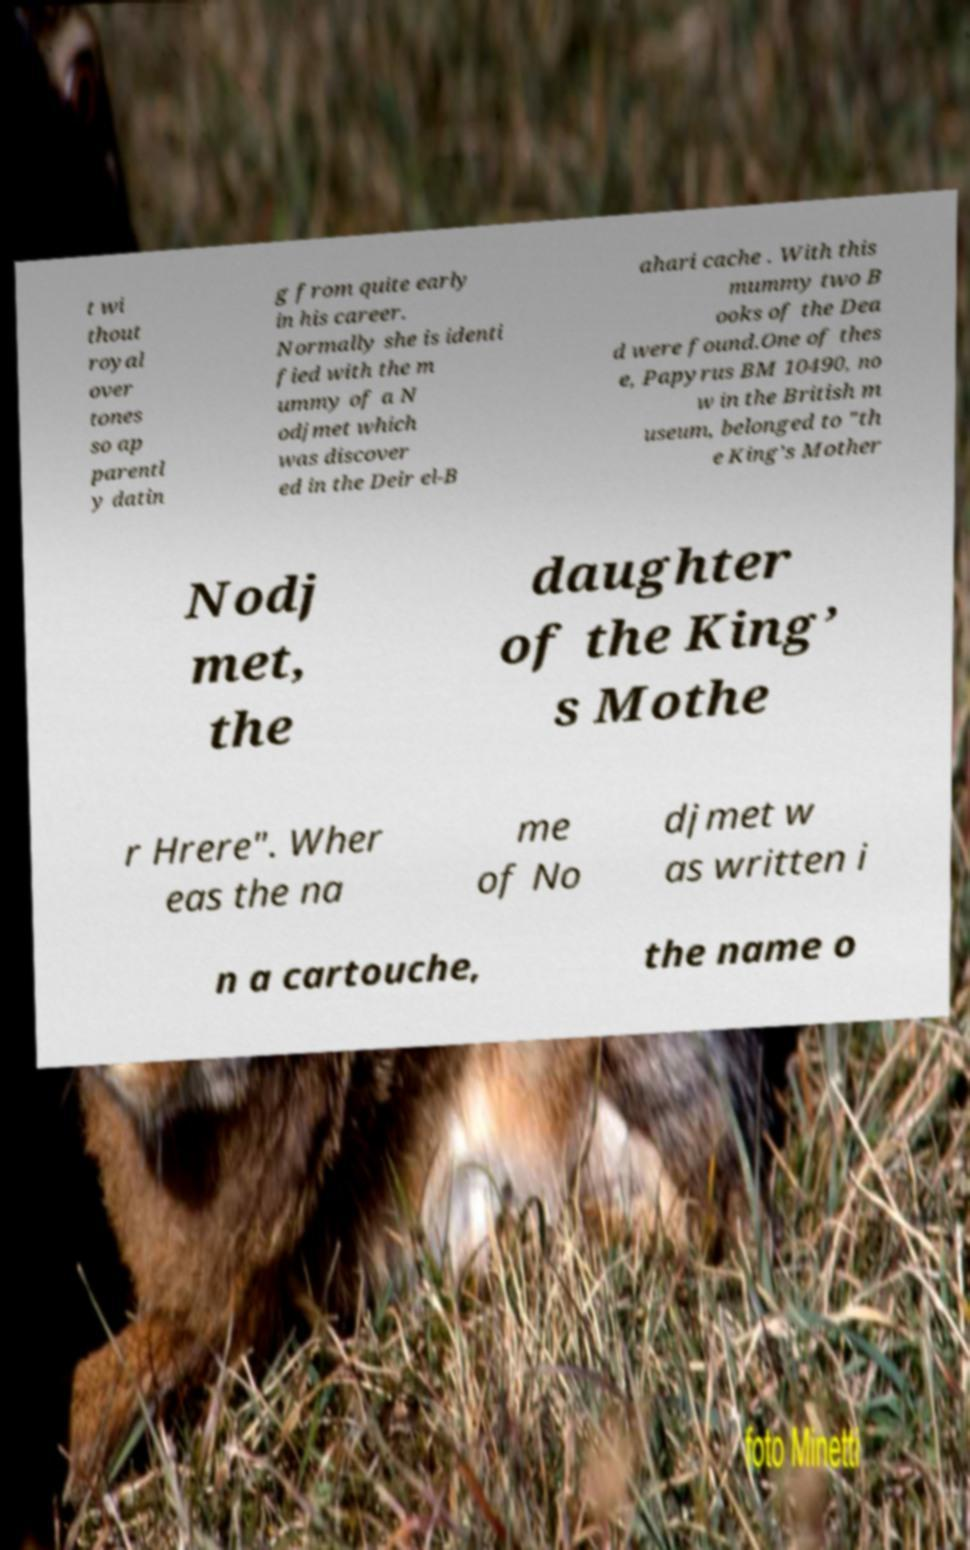Can you accurately transcribe the text from the provided image for me? t wi thout royal over tones so ap parentl y datin g from quite early in his career. Normally she is identi fied with the m ummy of a N odjmet which was discover ed in the Deir el-B ahari cache . With this mummy two B ooks of the Dea d were found.One of thes e, Papyrus BM 10490, no w in the British m useum, belonged to "th e King’s Mother Nodj met, the daughter of the King’ s Mothe r Hrere". Wher eas the na me of No djmet w as written i n a cartouche, the name o 